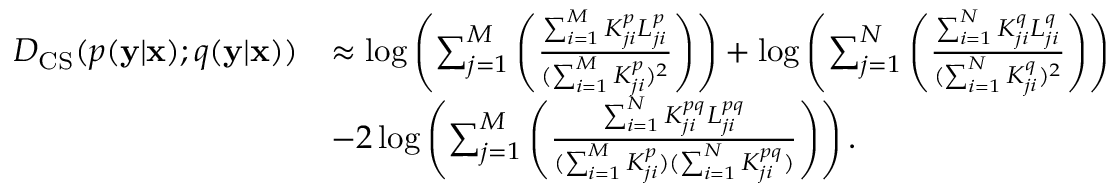<formula> <loc_0><loc_0><loc_500><loc_500>\begin{array} { r l } { D _ { C S } ( p ( y | x ) ; q ( y | x ) ) } & { \approx \log \left ( \sum _ { j = 1 } ^ { M } \left ( \frac { \sum _ { i = 1 } ^ { M } K _ { j i } ^ { p } L _ { j i } ^ { p } } { ( \sum _ { i = 1 } ^ { M } K _ { j i } ^ { p } ) ^ { 2 } } \right ) \right ) + \log \left ( \sum _ { j = 1 } ^ { N } \left ( \frac { \sum _ { i = 1 } ^ { N } K _ { j i } ^ { q } L _ { j i } ^ { q } } { ( \sum _ { i = 1 } ^ { N } K _ { j i } ^ { q } ) ^ { 2 } } \right ) \right ) } \\ & { - 2 \log \left ( \sum _ { j = 1 } ^ { M } \left ( \frac { \sum _ { i = 1 } ^ { N } K _ { j i } ^ { p q } L _ { j i } ^ { p q } } { ( \sum _ { i = 1 } ^ { M } K _ { j i } ^ { p } ) ( \sum _ { i = 1 } ^ { N } K _ { j i } ^ { p q } ) } \right ) \right ) . } \end{array}</formula> 